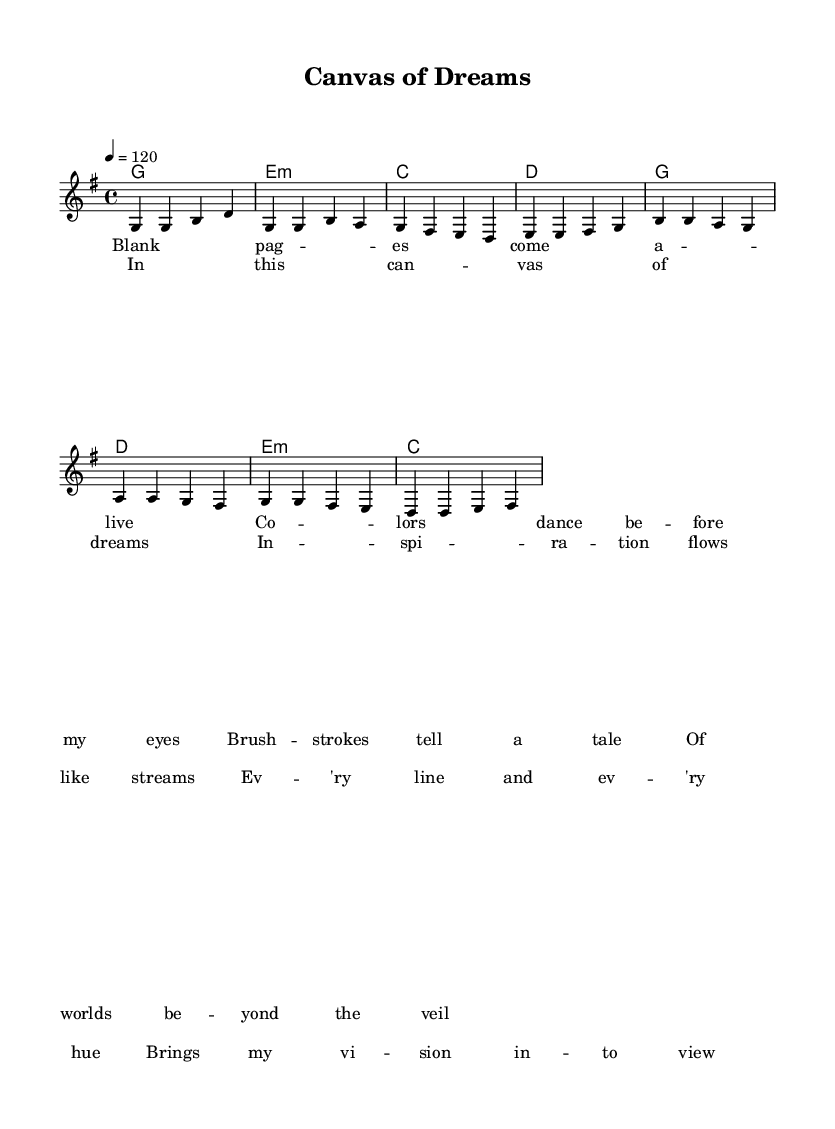What is the key signature of this music? The key signature is G major, which has one sharp note, F#.
Answer: G major What is the time signature of this piece? The time signature is 4/4, indicating four beats per measure.
Answer: 4/4 What is the tempo marking in this score? The tempo marking is 120, referring to the beat per minute (BPM).
Answer: 120 What are the first two words of the verse? The first two words of the verse are "Blank pages," as shown in the lyric section.
Answer: Blank pages How many measures are there in the chorus? The chorus consists of four measures, with two lines of lyrics corresponding to these measures.
Answer: 4 What chord is played during the first measure of the verse? The chord played during the first measure of the verse is G major, denoted by 'g1' in the chord progression.
Answer: G Which word appears last in the chorus lyrics? The last word in the chorus lyrics is "view," as indicated in the final measure of the chorus lyrics.
Answer: view 